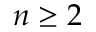Convert formula to latex. <formula><loc_0><loc_0><loc_500><loc_500>n \geq 2</formula> 